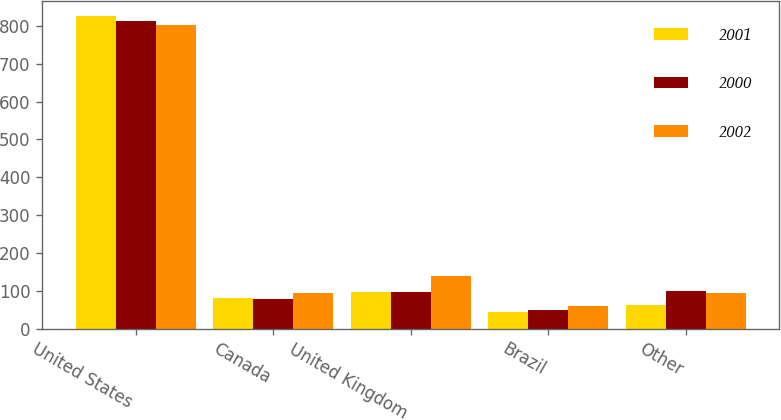Convert chart to OTSL. <chart><loc_0><loc_0><loc_500><loc_500><stacked_bar_chart><ecel><fcel>United States<fcel>Canada<fcel>United Kingdom<fcel>Brazil<fcel>Other<nl><fcel>2001<fcel>826<fcel>80.4<fcel>97.6<fcel>43.4<fcel>61.9<nl><fcel>2000<fcel>813.8<fcel>77.5<fcel>97.6<fcel>49.5<fcel>100.6<nl><fcel>2002<fcel>801.6<fcel>94.6<fcel>137.7<fcel>60.9<fcel>94.4<nl></chart> 